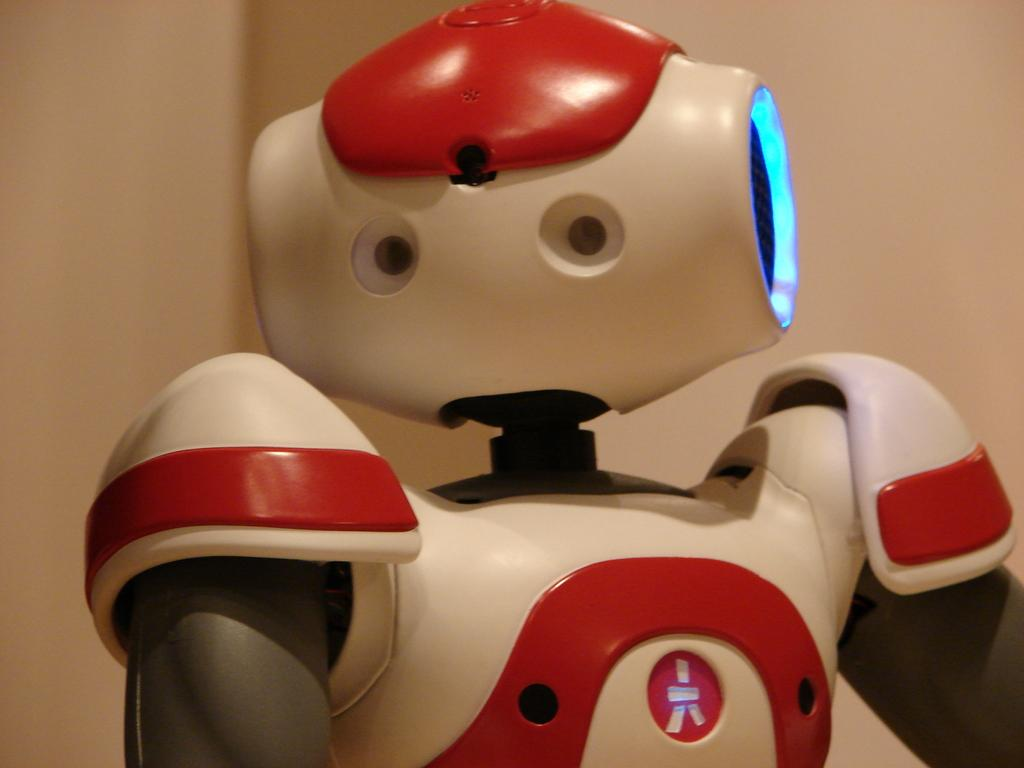What is the main subject of the image? The main subject of the image is a toy robot. What type of pancake is the toy robot holding in the image? There is no pancake present in the image; the main subject is a toy robot. 